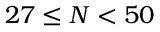Convert formula to latex. <formula><loc_0><loc_0><loc_500><loc_500>2 7 \leq N < 5 0</formula> 